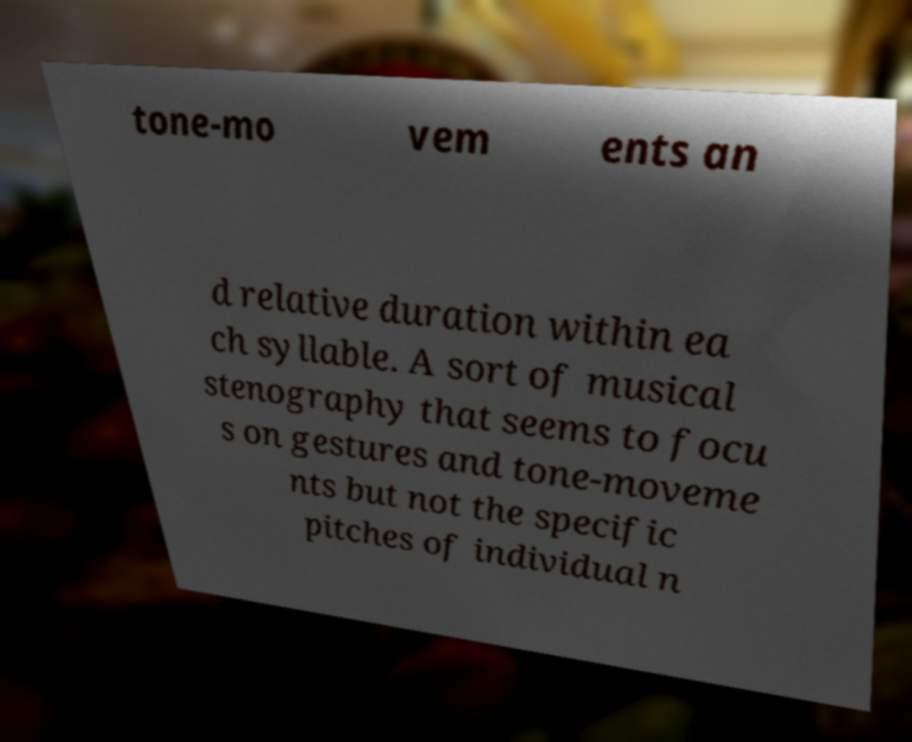Please identify and transcribe the text found in this image. tone-mo vem ents an d relative duration within ea ch syllable. A sort of musical stenography that seems to focu s on gestures and tone-moveme nts but not the specific pitches of individual n 